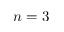Convert formula to latex. <formula><loc_0><loc_0><loc_500><loc_500>n = 3</formula> 